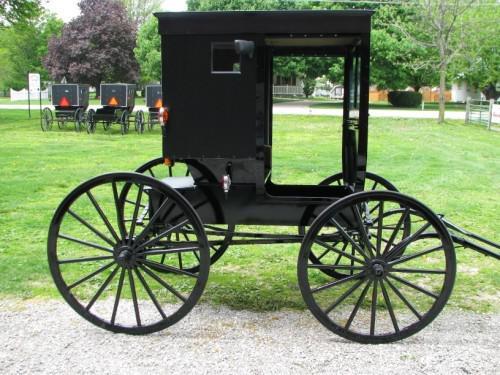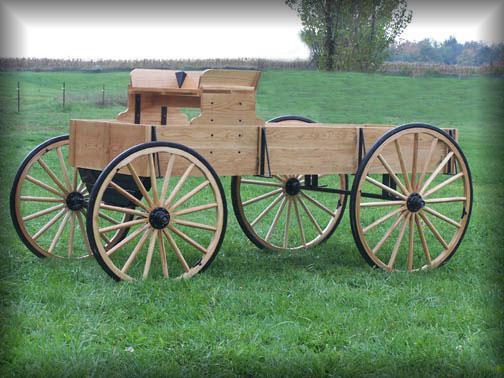The first image is the image on the left, the second image is the image on the right. For the images displayed, is the sentence "An image shows a brown horse harnessed to pull some type of wheeled thing." factually correct? Answer yes or no. No. The first image is the image on the left, the second image is the image on the right. Analyze the images presented: Is the assertion "There is a picture showing a horse hitched up to a piece of equipment." valid? Answer yes or no. No. 